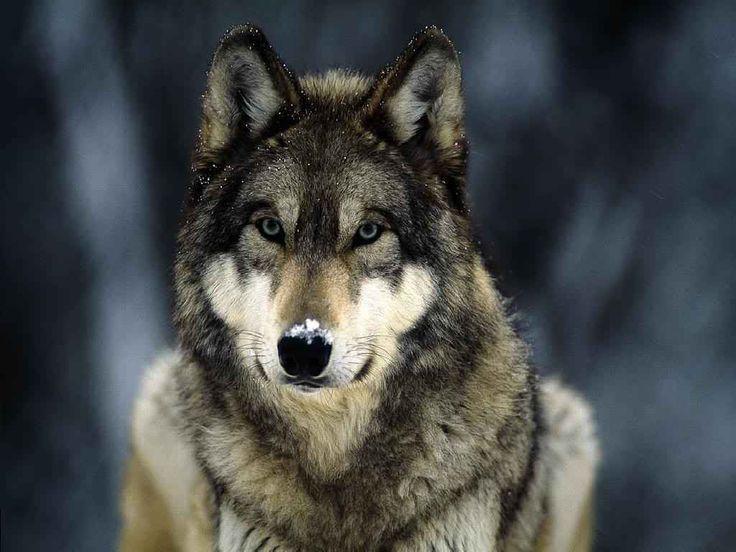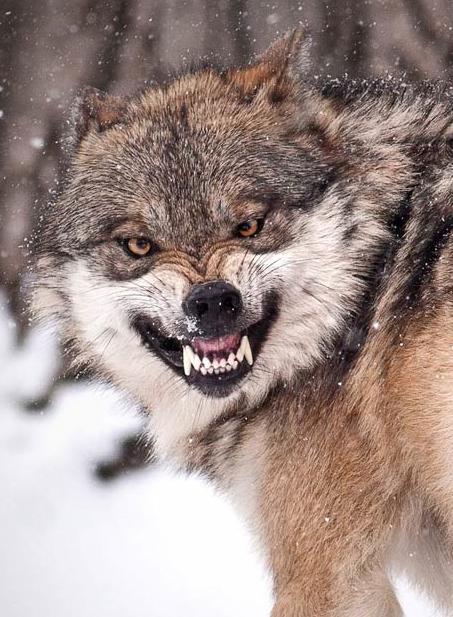The first image is the image on the left, the second image is the image on the right. Analyze the images presented: Is the assertion "At least one image shows a wold standing on all fours in a nonsnowy setting." valid? Answer yes or no. No. 